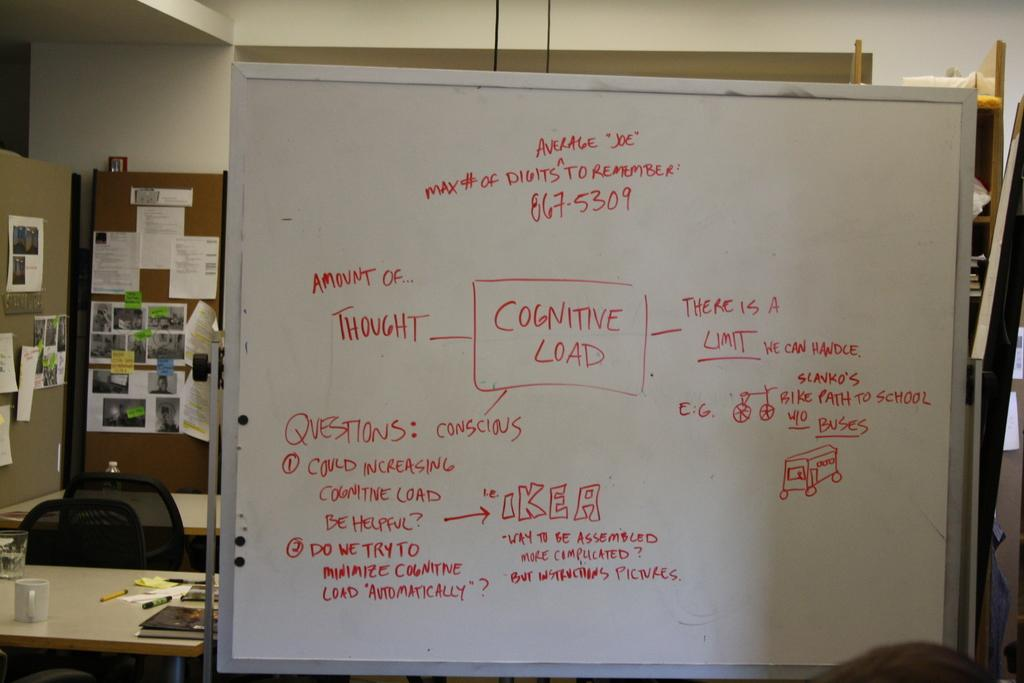<image>
Share a concise interpretation of the image provided. A white board with red writing on it and the center titled Cognitive Load and the board is in the office 